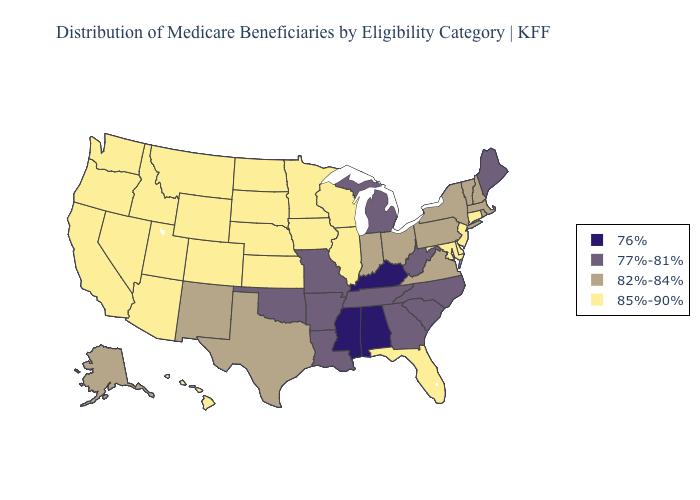What is the value of Mississippi?
Be succinct. 76%. What is the value of South Dakota?
Short answer required. 85%-90%. Name the states that have a value in the range 85%-90%?
Answer briefly. Arizona, California, Colorado, Connecticut, Delaware, Florida, Hawaii, Idaho, Illinois, Iowa, Kansas, Maryland, Minnesota, Montana, Nebraska, Nevada, New Jersey, North Dakota, Oregon, South Dakota, Utah, Washington, Wisconsin, Wyoming. Does Nevada have the lowest value in the USA?
Give a very brief answer. No. Which states hav the highest value in the South?
Keep it brief. Delaware, Florida, Maryland. What is the value of Illinois?
Keep it brief. 85%-90%. What is the value of Iowa?
Be succinct. 85%-90%. What is the value of Indiana?
Keep it brief. 82%-84%. Name the states that have a value in the range 82%-84%?
Short answer required. Alaska, Indiana, Massachusetts, New Hampshire, New Mexico, New York, Ohio, Pennsylvania, Rhode Island, Texas, Vermont, Virginia. What is the value of Hawaii?
Write a very short answer. 85%-90%. Name the states that have a value in the range 82%-84%?
Give a very brief answer. Alaska, Indiana, Massachusetts, New Hampshire, New Mexico, New York, Ohio, Pennsylvania, Rhode Island, Texas, Vermont, Virginia. Does Montana have the highest value in the USA?
Write a very short answer. Yes. Name the states that have a value in the range 77%-81%?
Quick response, please. Arkansas, Georgia, Louisiana, Maine, Michigan, Missouri, North Carolina, Oklahoma, South Carolina, Tennessee, West Virginia. Among the states that border Delaware , which have the highest value?
Answer briefly. Maryland, New Jersey. What is the value of Alaska?
Be succinct. 82%-84%. 